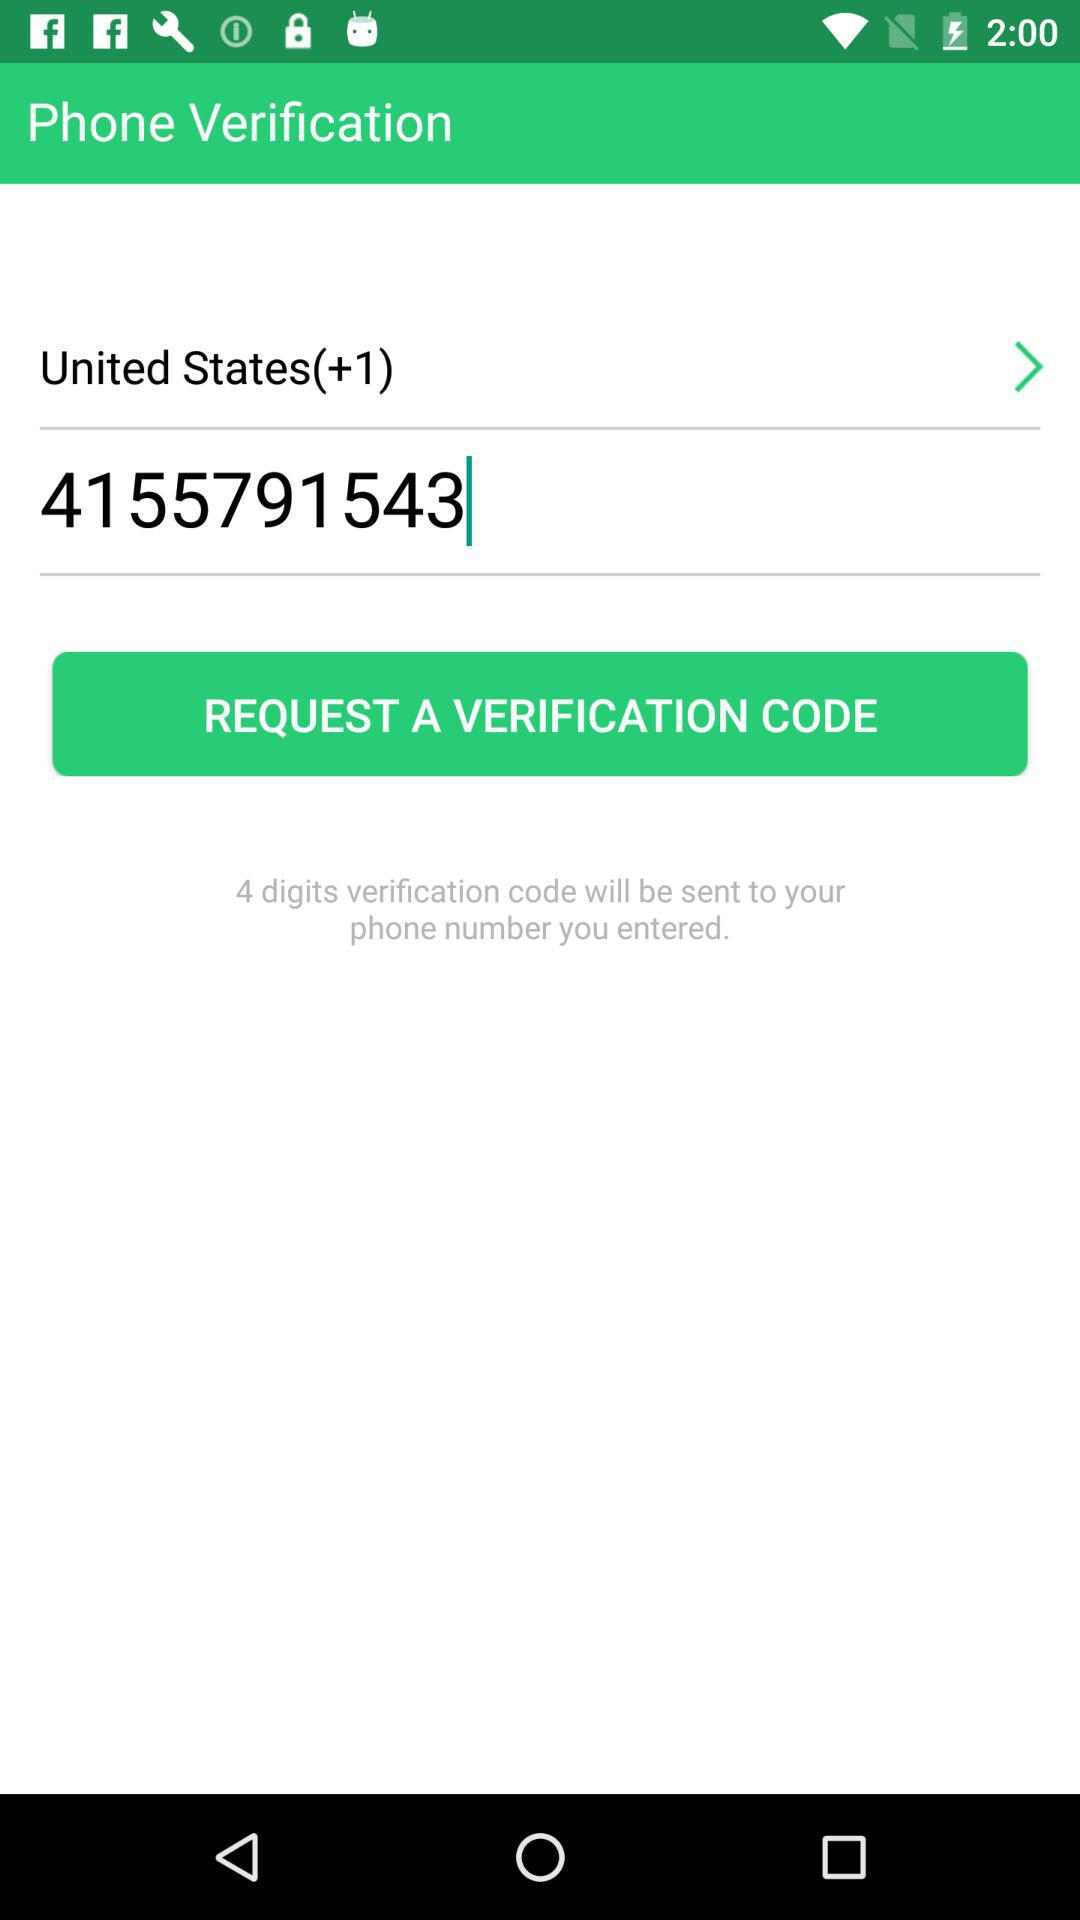What is country code for United States? The country code for the United States is +1. 